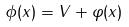<formula> <loc_0><loc_0><loc_500><loc_500>\phi ( x ) = V + \varphi ( x )</formula> 